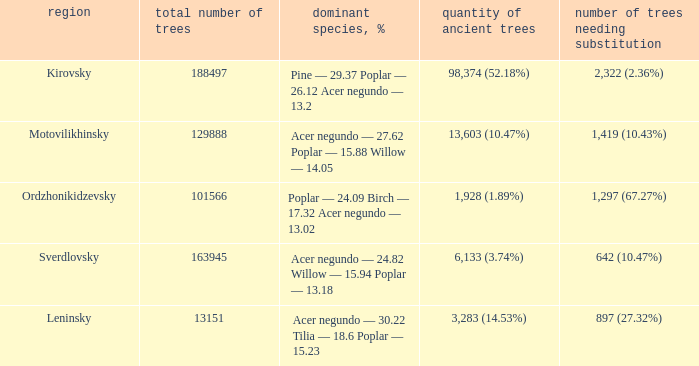What is the amount of trees, that require replacement when the district is motovilikhinsky? 1,419 (10.43%). 